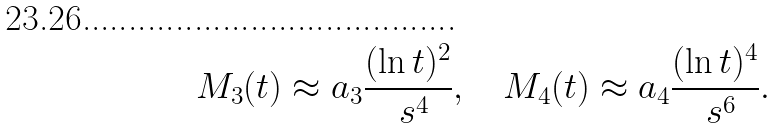<formula> <loc_0><loc_0><loc_500><loc_500>M _ { 3 } ( t ) \approx a _ { 3 } \frac { ( \ln t ) ^ { 2 } } { \ s ^ { 4 } } , \quad M _ { 4 } ( t ) \approx a _ { 4 } \frac { ( \ln t ) ^ { 4 } } { \ s ^ { 6 } } .</formula> 